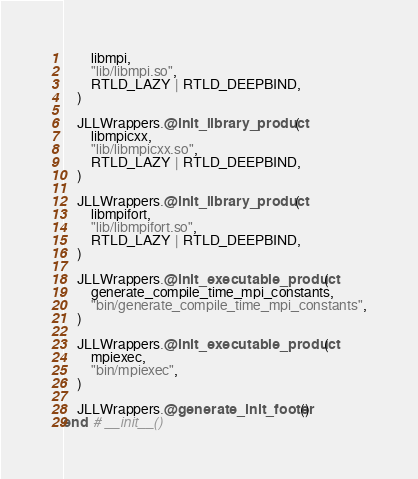Convert code to text. <code><loc_0><loc_0><loc_500><loc_500><_Julia_>        libmpi,
        "lib/libmpi.so",
        RTLD_LAZY | RTLD_DEEPBIND,
    )

    JLLWrappers.@init_library_product(
        libmpicxx,
        "lib/libmpicxx.so",
        RTLD_LAZY | RTLD_DEEPBIND,
    )

    JLLWrappers.@init_library_product(
        libmpifort,
        "lib/libmpifort.so",
        RTLD_LAZY | RTLD_DEEPBIND,
    )

    JLLWrappers.@init_executable_product(
        generate_compile_time_mpi_constants,
        "bin/generate_compile_time_mpi_constants",
    )

    JLLWrappers.@init_executable_product(
        mpiexec,
        "bin/mpiexec",
    )

    JLLWrappers.@generate_init_footer()
end  # __init__()
</code> 